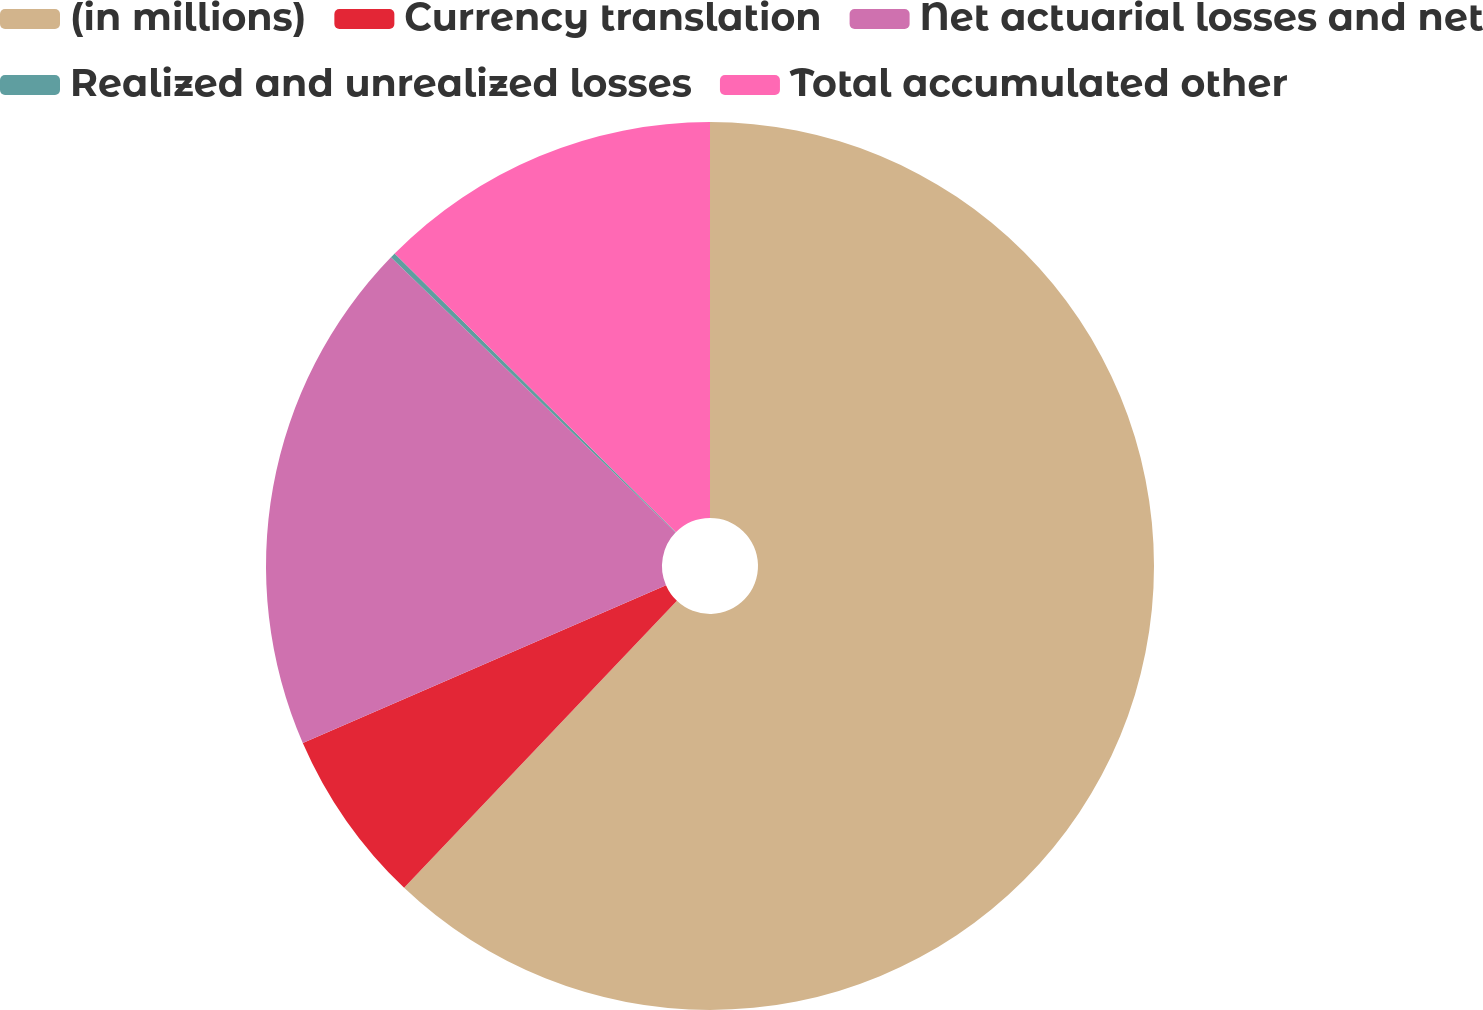<chart> <loc_0><loc_0><loc_500><loc_500><pie_chart><fcel>(in millions)<fcel>Currency translation<fcel>Net actuarial losses and net<fcel>Realized and unrealized losses<fcel>Total accumulated other<nl><fcel>62.09%<fcel>6.38%<fcel>18.76%<fcel>0.19%<fcel>12.57%<nl></chart> 